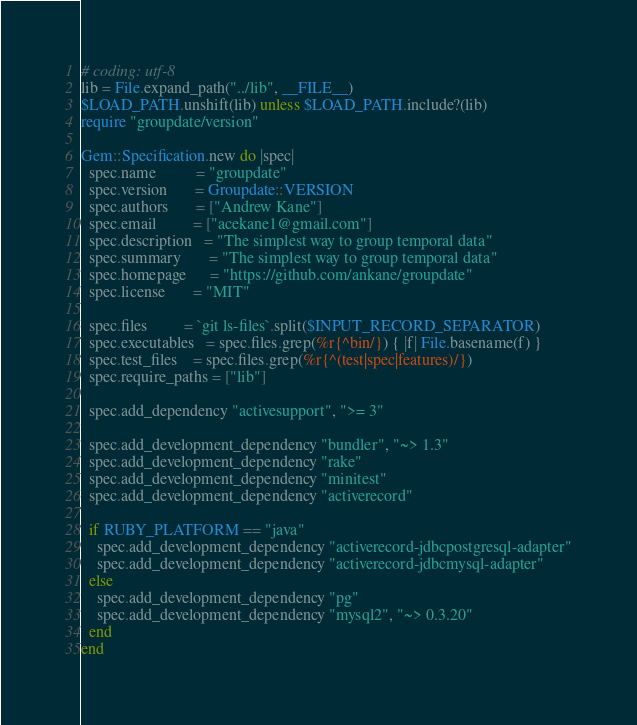Convert code to text. <code><loc_0><loc_0><loc_500><loc_500><_Ruby_># coding: utf-8
lib = File.expand_path("../lib", __FILE__)
$LOAD_PATH.unshift(lib) unless $LOAD_PATH.include?(lib)
require "groupdate/version"

Gem::Specification.new do |spec|
  spec.name          = "groupdate"
  spec.version       = Groupdate::VERSION
  spec.authors       = ["Andrew Kane"]
  spec.email         = ["acekane1@gmail.com"]
  spec.description   = "The simplest way to group temporal data"
  spec.summary       = "The simplest way to group temporal data"
  spec.homepage      = "https://github.com/ankane/groupdate"
  spec.license       = "MIT"

  spec.files         = `git ls-files`.split($INPUT_RECORD_SEPARATOR)
  spec.executables   = spec.files.grep(%r{^bin/}) { |f| File.basename(f) }
  spec.test_files    = spec.files.grep(%r{^(test|spec|features)/})
  spec.require_paths = ["lib"]

  spec.add_dependency "activesupport", ">= 3"

  spec.add_development_dependency "bundler", "~> 1.3"
  spec.add_development_dependency "rake"
  spec.add_development_dependency "minitest"
  spec.add_development_dependency "activerecord"

  if RUBY_PLATFORM == "java"
    spec.add_development_dependency "activerecord-jdbcpostgresql-adapter"
    spec.add_development_dependency "activerecord-jdbcmysql-adapter"
  else
    spec.add_development_dependency "pg"
    spec.add_development_dependency "mysql2", "~> 0.3.20"
  end
end
</code> 